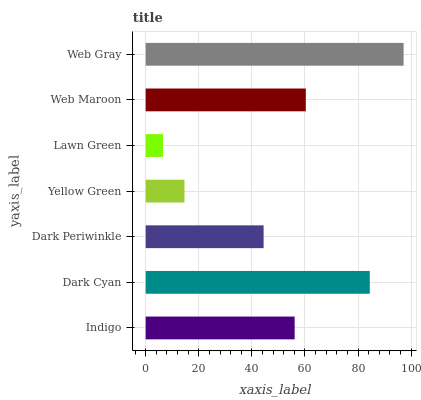Is Lawn Green the minimum?
Answer yes or no. Yes. Is Web Gray the maximum?
Answer yes or no. Yes. Is Dark Cyan the minimum?
Answer yes or no. No. Is Dark Cyan the maximum?
Answer yes or no. No. Is Dark Cyan greater than Indigo?
Answer yes or no. Yes. Is Indigo less than Dark Cyan?
Answer yes or no. Yes. Is Indigo greater than Dark Cyan?
Answer yes or no. No. Is Dark Cyan less than Indigo?
Answer yes or no. No. Is Indigo the high median?
Answer yes or no. Yes. Is Indigo the low median?
Answer yes or no. Yes. Is Web Maroon the high median?
Answer yes or no. No. Is Web Maroon the low median?
Answer yes or no. No. 